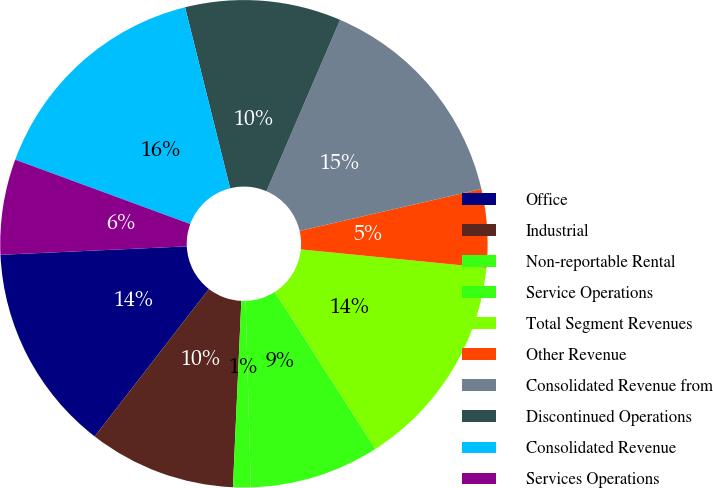<chart> <loc_0><loc_0><loc_500><loc_500><pie_chart><fcel>Office<fcel>Industrial<fcel>Non-reportable Rental<fcel>Service Operations<fcel>Total Segment Revenues<fcel>Other Revenue<fcel>Consolidated Revenue from<fcel>Discontinued Operations<fcel>Consolidated Revenue<fcel>Services Operations<nl><fcel>13.79%<fcel>9.77%<fcel>1.17%<fcel>8.62%<fcel>14.36%<fcel>5.18%<fcel>14.93%<fcel>10.34%<fcel>15.51%<fcel>6.33%<nl></chart> 